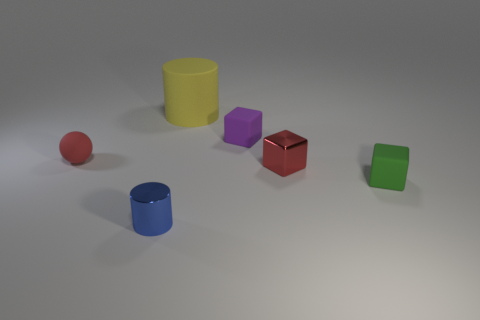Subtract all tiny red metal blocks. How many blocks are left? 2 Add 4 yellow objects. How many objects exist? 10 Subtract 2 cylinders. How many cylinders are left? 0 Subtract all green blocks. How many blocks are left? 2 Subtract all cylinders. How many objects are left? 4 Subtract all small red metal cubes. Subtract all yellow rubber things. How many objects are left? 4 Add 2 red things. How many red things are left? 4 Add 4 red things. How many red things exist? 6 Subtract 0 purple balls. How many objects are left? 6 Subtract all green cylinders. Subtract all red spheres. How many cylinders are left? 2 